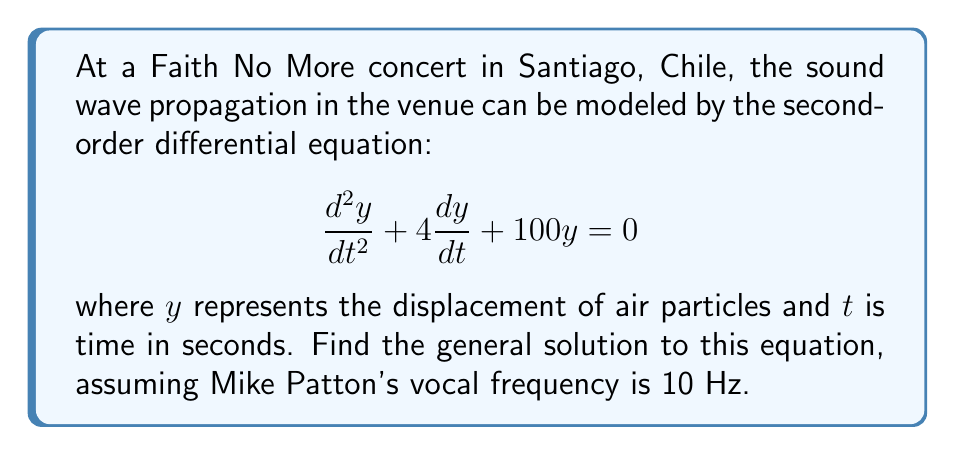Can you solve this math problem? To solve this second-order linear differential equation, we follow these steps:

1) First, we identify the characteristic equation:
   $$r^2 + 4r + 100 = 0$$

2) We solve this quadratic equation:
   $$r = \frac{-4 \pm \sqrt{4^2 - 4(1)(100)}}{2(1)} = \frac{-4 \pm \sqrt{16 - 400}}{2} = \frac{-4 \pm \sqrt{-384}}{2}$$

3) Simplify:
   $$r = -2 \pm i\sqrt{96} = -2 \pm 4\sqrt{6}i$$

4) Therefore, the roots are:
   $$r_1 = -2 + 4\sqrt{6}i \quad \text{and} \quad r_2 = -2 - 4\sqrt{6}i$$

5) The general solution for this type of equation (with complex roots) is:
   $$y(t) = e^{at}(c_1\cos(bt) + c_2\sin(bt))$$
   where $a$ is the real part of the roots and $b$ is the imaginary part.

6) In this case, $a = -2$ and $b = 4\sqrt{6}$, so our solution is:
   $$y(t) = e^{-2t}(c_1\cos(4\sqrt{6}t) + c_2\sin(4\sqrt{6}t))$$

7) Given that Mike Patton's vocal frequency is 10 Hz, we can relate this to the angular frequency $\omega = 2\pi f = 20\pi$ rad/s. This doesn't directly affect our solution, but it provides context for the sound wave's behavior in the venue.
Answer: $$y(t) = e^{-2t}(c_1\cos(4\sqrt{6}t) + c_2\sin(4\sqrt{6}t))$$
where $c_1$ and $c_2$ are arbitrary constants determined by initial conditions. 